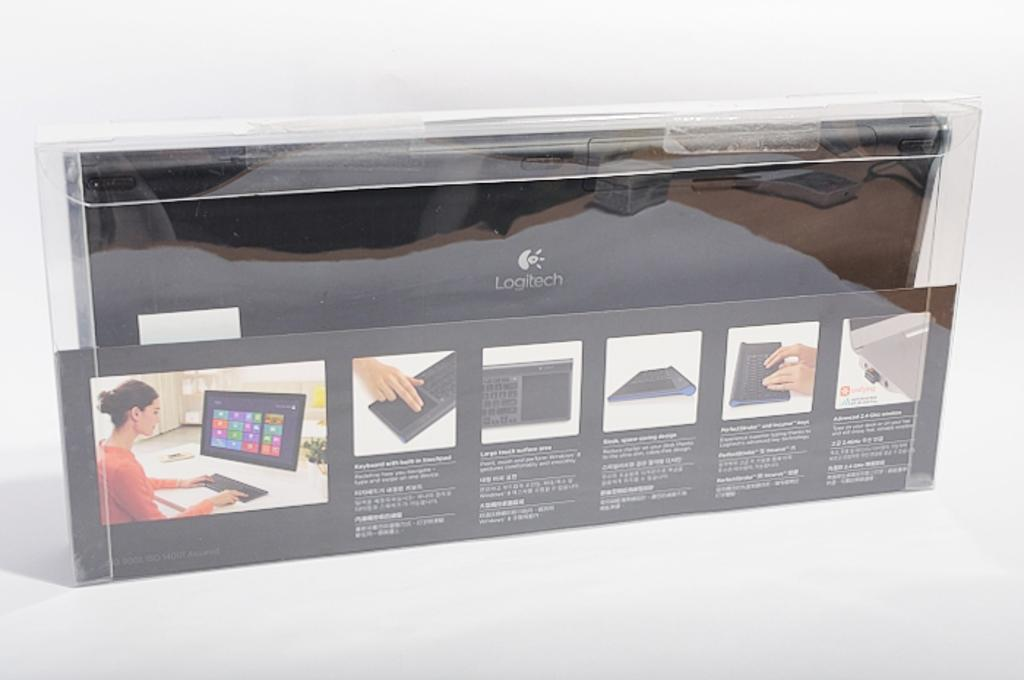<image>
Summarize the visual content of the image. A black Logitech keyboard and touchpad in a clear case. 